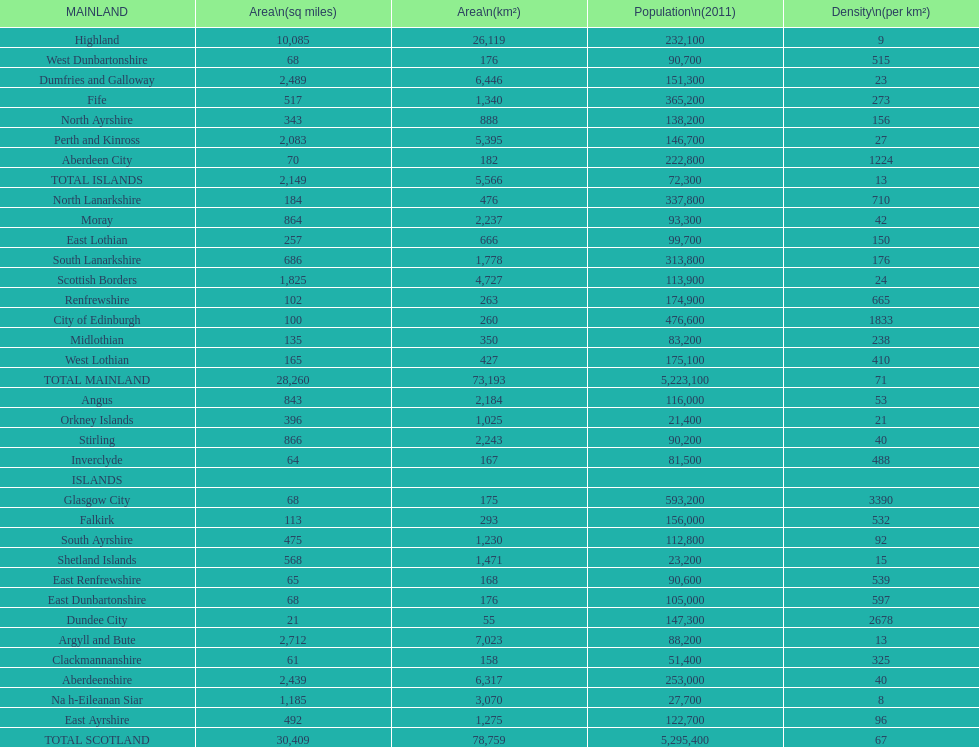If you were to arrange the locations from the smallest to largest area, which one would be first on the list? Dundee City. 